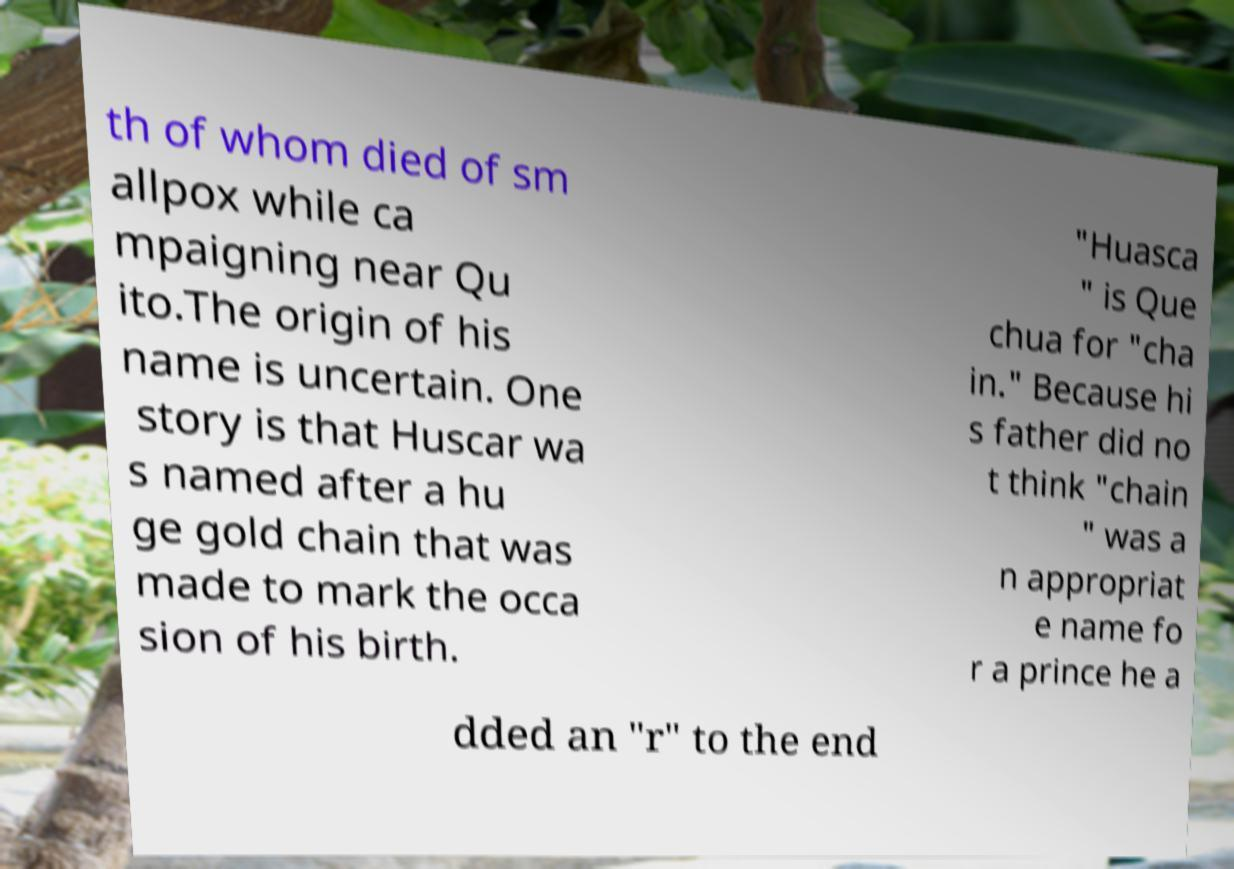I need the written content from this picture converted into text. Can you do that? th of whom died of sm allpox while ca mpaigning near Qu ito.The origin of his name is uncertain. One story is that Huscar wa s named after a hu ge gold chain that was made to mark the occa sion of his birth. "Huasca " is Que chua for "cha in." Because hi s father did no t think "chain " was a n appropriat e name fo r a prince he a dded an "r" to the end 